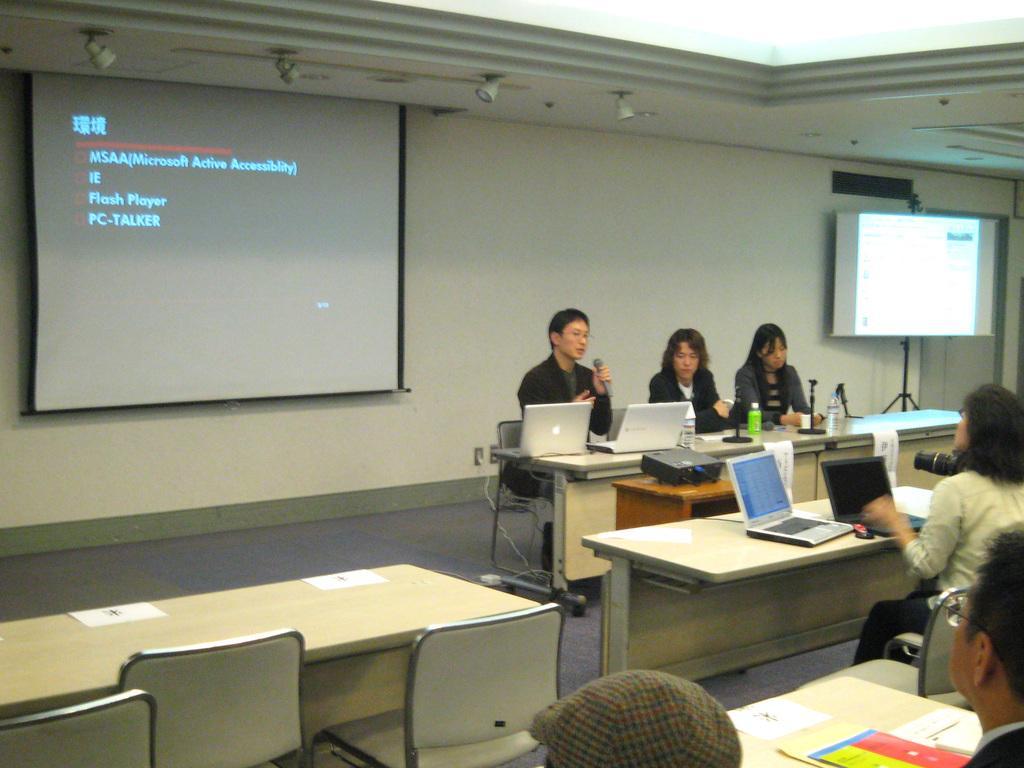In one or two sentences, can you explain what this image depicts? The picture is clicked in a room, in the room there are tables and chairs. In the left there are sitting besides a table and facing forward. Towards the left corner there are two persons sitting on chairs are facing backwards. In the background there is a wall and a screen. 